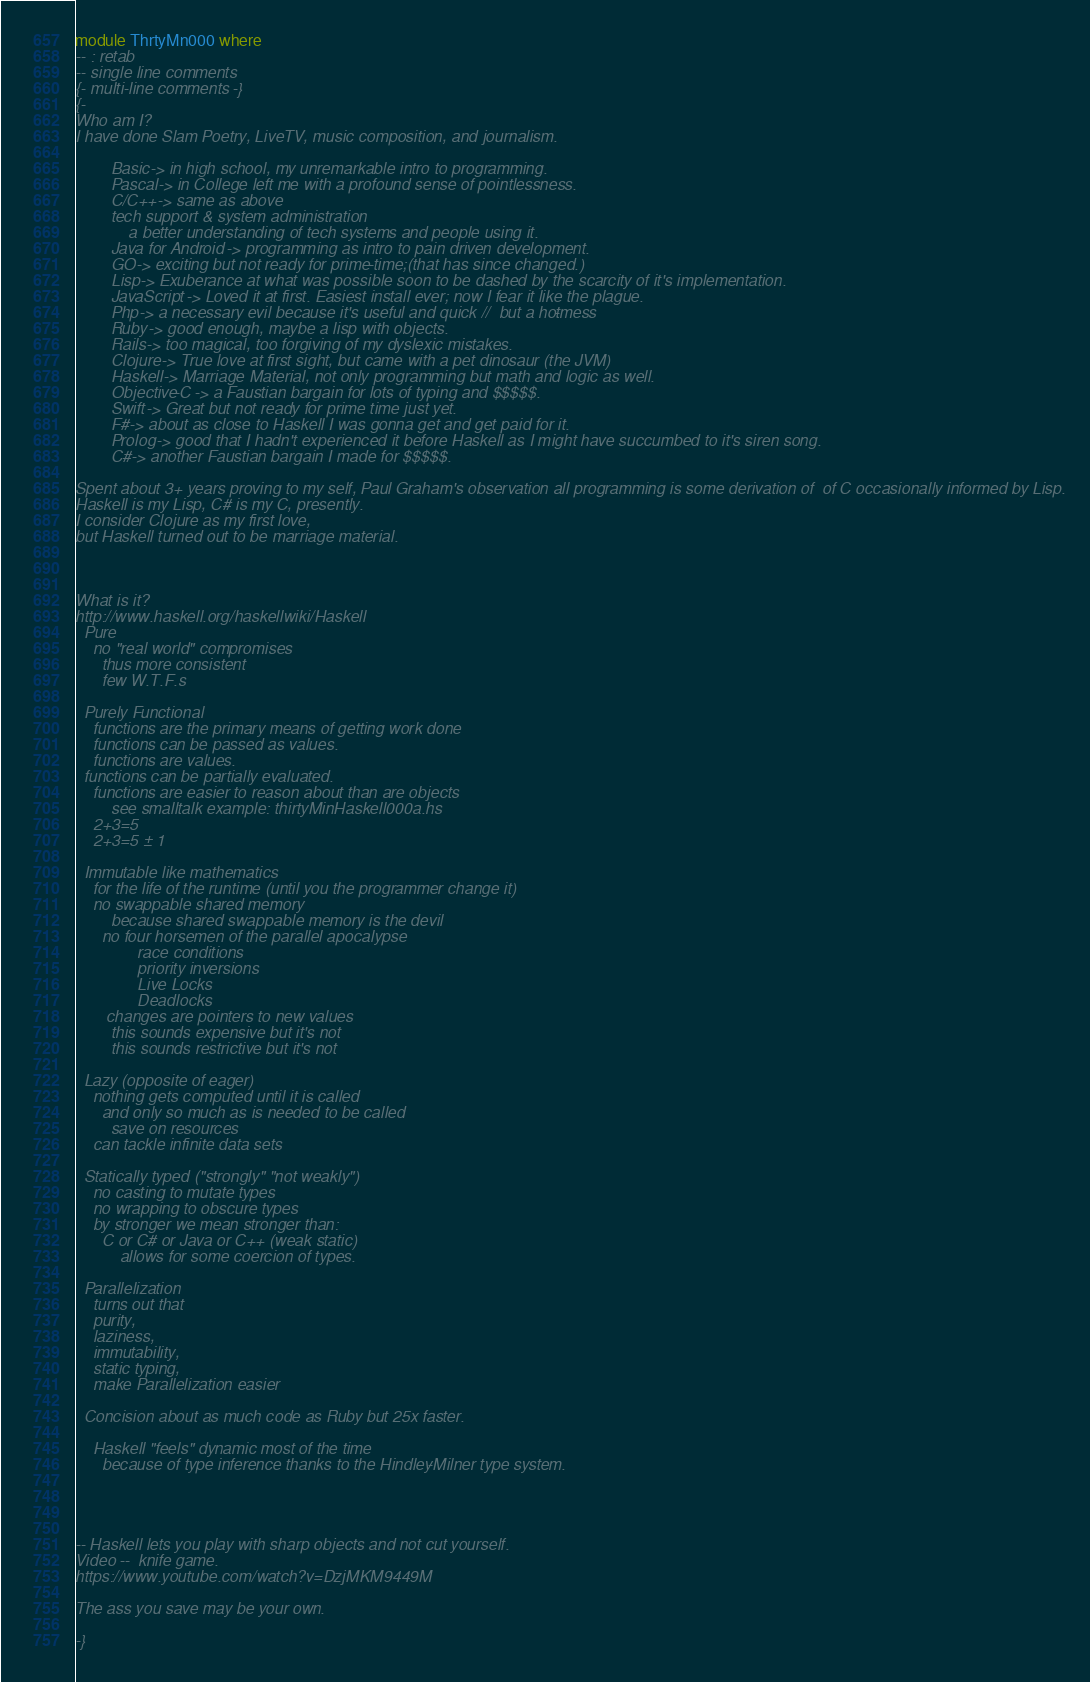<code> <loc_0><loc_0><loc_500><loc_500><_Haskell_>module ThrtyMn000 where 
-- : retab 
-- single line comments 
{- multi-line comments -} 
{- 
Who am I? 
I have done Slam Poetry, LiveTV, music composition, and journalism.  

        Basic -> in high school, my unremarkable intro to programming. 
        Pascal -> in College left me with a profound sense of pointlessness. 
        C/C++ -> same as above
        tech support & system administration 
            a better understanding of tech systems and people using it.
        Java for Android -> programming as intro to pain driven development. 
        GO -> exciting but not ready for prime-time;(that has since changed.)
        Lisp -> Exuberance at what was possible soon to be dashed by the scarcity of it's implementation.
        JavaScript -> Loved it at first. Easiest install ever; now I fear it like the plague. 
        Php -> a necessary evil because it's useful and quick //  but a hot-mess
        Ruby -> good enough, maybe a lisp with objects.  
        Rails -> too magical, too forgiving of my dyslexic mistakes.
        Clojure -> True love at first sight, but came with a pet dinosaur (the JVM)  
        Haskell -> Marriage Material, not only programming but math and logic as well. 
        Objective-C -> a Faustian bargain for lots of typing and $$$$$.  
        Swift -> Great but not ready for prime time just yet.
        F# -> about as close to Haskell I was gonna get and get paid for it.
        Prolog -> good that I hadn't experienced it before Haskell as I might have succumbed to it's siren song.
        C# -> another Faustian bargain I made for $$$$$.
 
Spent about 3+ years proving to my self, Paul Graham's observation all programming is some derivation of  of C occasionally informed by Lisp.
Haskell is my Lisp, C# is my C, presently. 
I consider Clojure as my first love, 
but Haskell turned out to be marriage material. 



What is it? 
http://www.haskell.org/haskellwiki/Haskell
  Pure 
    no "real world" compromises
      thus more consistent 
      few W.T.F.s  

  Purely Functional 
    functions are the primary means of getting work done 
    functions can be passed as values. 
    functions are values.
  functions can be partially evaluated.
    functions are easier to reason about than are objects
        see smalltalk example: thirtyMinHaskell000a.hs 
    2+3=5
    2+3=5 ± 1  

  Immutable like mathematics
    for the life of the runtime (until you the programmer change it)  
    no swappable shared memory
        because shared swappable memory is the devil 
      no four horsemen of the parallel apocalypse 
              race conditions 
              priority inversions
              Live Locks 
              Deadlocks
       changes are pointers to new values
        this sounds expensive but it's not
        this sounds restrictive but it's not

  Lazy (opposite of eager)
    nothing gets computed until it is called
      and only so much as is needed to be called
        save on resources 
    can tackle infinite data sets 

  Statically typed ("strongly" "not weakly") 
    no casting to mutate types
    no wrapping to obscure types
    by stronger we mean stronger than: 
      C or C# or Java or C++ (weak static) 
          allows for some coercion of types.

  Parallelization 
    turns out that 
    purity, 
    laziness, 
    immutability, 
    static typing, 
    make Parallelization easier
    
  Concision about as much code as Ruby but 25x faster. 
 
    Haskell "feels" dynamic most of the time   
      because of type inference thanks to the Hindley-Milner type system.


 

-- Haskell lets you play with sharp objects and not cut yourself. 
Video --  knife game.
https://www.youtube.com/watch?v=DzjMKM9449M

The ass you save may be your own.

-}    





</code> 